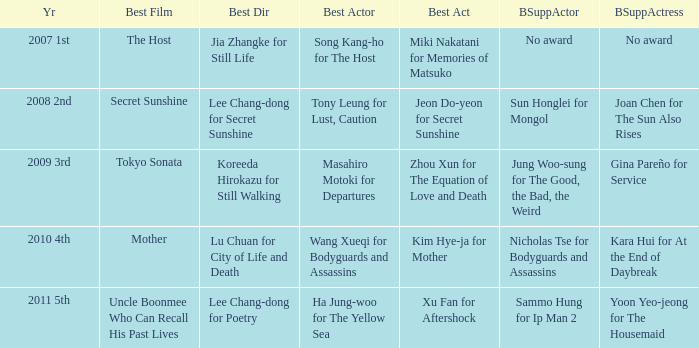Name the best director for mother Lu Chuan for City of Life and Death. 